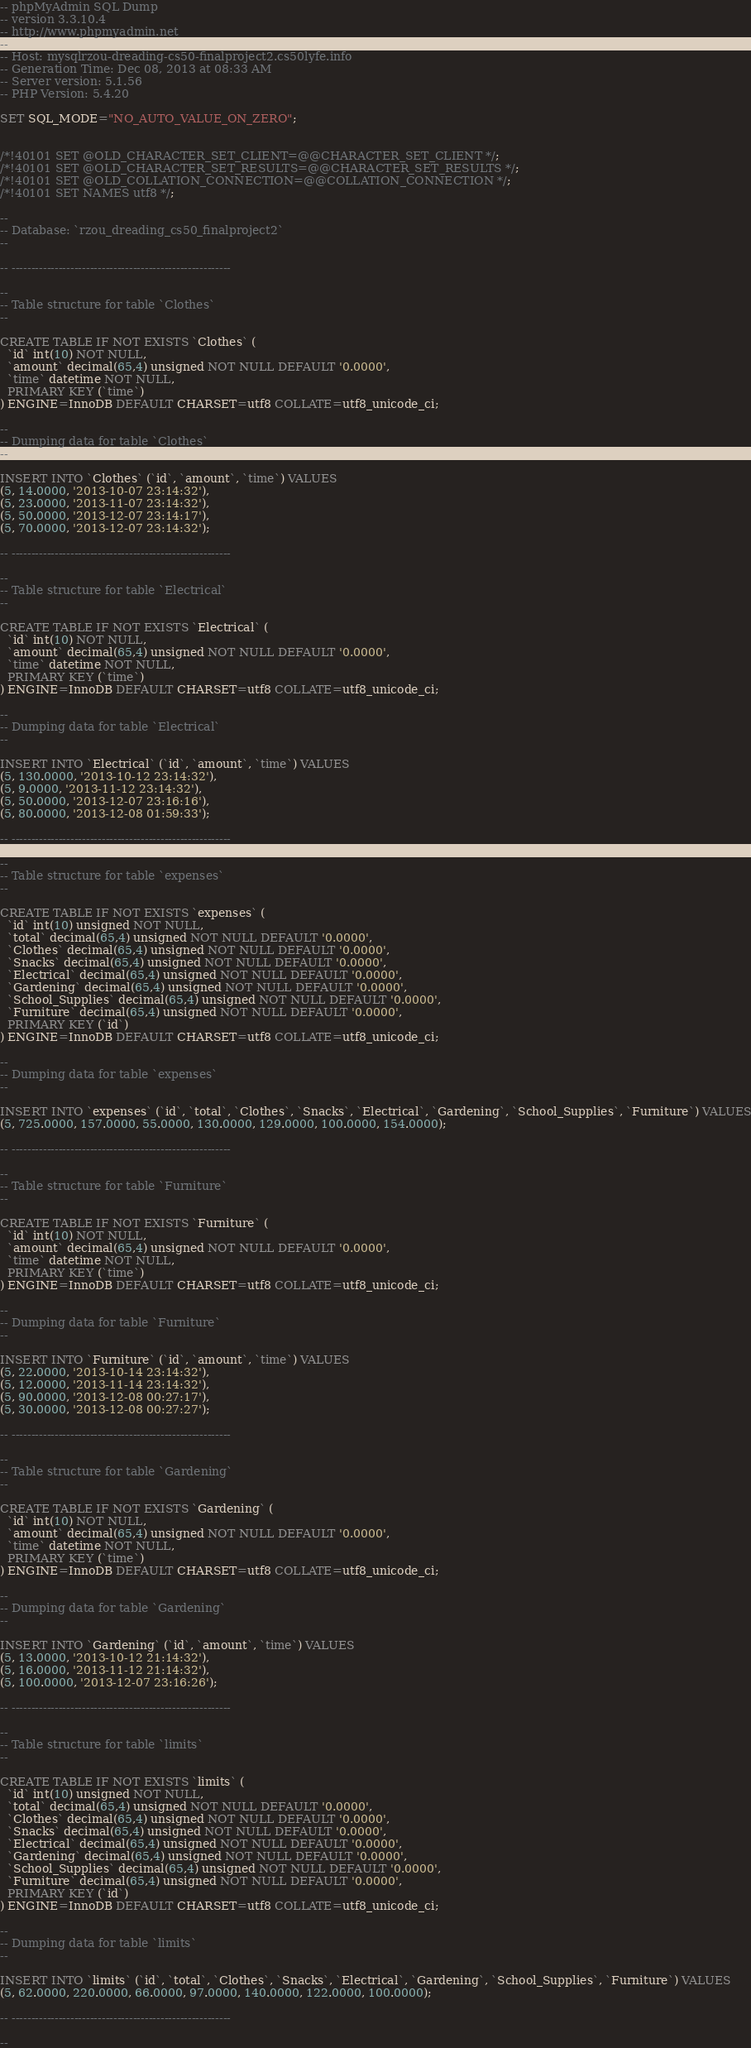<code> <loc_0><loc_0><loc_500><loc_500><_SQL_>-- phpMyAdmin SQL Dump
-- version 3.3.10.4
-- http://www.phpmyadmin.net
--
-- Host: mysqlrzou-dreading-cs50-finalproject2.cs50lyfe.info
-- Generation Time: Dec 08, 2013 at 08:33 AM
-- Server version: 5.1.56
-- PHP Version: 5.4.20

SET SQL_MODE="NO_AUTO_VALUE_ON_ZERO";


/*!40101 SET @OLD_CHARACTER_SET_CLIENT=@@CHARACTER_SET_CLIENT */;
/*!40101 SET @OLD_CHARACTER_SET_RESULTS=@@CHARACTER_SET_RESULTS */;
/*!40101 SET @OLD_COLLATION_CONNECTION=@@COLLATION_CONNECTION */;
/*!40101 SET NAMES utf8 */;

--
-- Database: `rzou_dreading_cs50_finalproject2`
--

-- --------------------------------------------------------

--
-- Table structure for table `Clothes`
--

CREATE TABLE IF NOT EXISTS `Clothes` (
  `id` int(10) NOT NULL,
  `amount` decimal(65,4) unsigned NOT NULL DEFAULT '0.0000',
  `time` datetime NOT NULL,
  PRIMARY KEY (`time`)
) ENGINE=InnoDB DEFAULT CHARSET=utf8 COLLATE=utf8_unicode_ci;

--
-- Dumping data for table `Clothes`
--

INSERT INTO `Clothes` (`id`, `amount`, `time`) VALUES
(5, 14.0000, '2013-10-07 23:14:32'),
(5, 23.0000, '2013-11-07 23:14:32'),
(5, 50.0000, '2013-12-07 23:14:17'),
(5, 70.0000, '2013-12-07 23:14:32');

-- --------------------------------------------------------

--
-- Table structure for table `Electrical`
--

CREATE TABLE IF NOT EXISTS `Electrical` (
  `id` int(10) NOT NULL,
  `amount` decimal(65,4) unsigned NOT NULL DEFAULT '0.0000',
  `time` datetime NOT NULL,
  PRIMARY KEY (`time`)
) ENGINE=InnoDB DEFAULT CHARSET=utf8 COLLATE=utf8_unicode_ci;

--
-- Dumping data for table `Electrical`
--

INSERT INTO `Electrical` (`id`, `amount`, `time`) VALUES
(5, 130.0000, '2013-10-12 23:14:32'),
(5, 9.0000, '2013-11-12 23:14:32'),
(5, 50.0000, '2013-12-07 23:16:16'),
(5, 80.0000, '2013-12-08 01:59:33');

-- --------------------------------------------------------

--
-- Table structure for table `expenses`
--

CREATE TABLE IF NOT EXISTS `expenses` (
  `id` int(10) unsigned NOT NULL,
  `total` decimal(65,4) unsigned NOT NULL DEFAULT '0.0000',
  `Clothes` decimal(65,4) unsigned NOT NULL DEFAULT '0.0000',
  `Snacks` decimal(65,4) unsigned NOT NULL DEFAULT '0.0000',
  `Electrical` decimal(65,4) unsigned NOT NULL DEFAULT '0.0000',
  `Gardening` decimal(65,4) unsigned NOT NULL DEFAULT '0.0000',
  `School_Supplies` decimal(65,4) unsigned NOT NULL DEFAULT '0.0000',
  `Furniture` decimal(65,4) unsigned NOT NULL DEFAULT '0.0000',
  PRIMARY KEY (`id`)
) ENGINE=InnoDB DEFAULT CHARSET=utf8 COLLATE=utf8_unicode_ci;

--
-- Dumping data for table `expenses`
--

INSERT INTO `expenses` (`id`, `total`, `Clothes`, `Snacks`, `Electrical`, `Gardening`, `School_Supplies`, `Furniture`) VALUES
(5, 725.0000, 157.0000, 55.0000, 130.0000, 129.0000, 100.0000, 154.0000);

-- --------------------------------------------------------

--
-- Table structure for table `Furniture`
--

CREATE TABLE IF NOT EXISTS `Furniture` (
  `id` int(10) NOT NULL,
  `amount` decimal(65,4) unsigned NOT NULL DEFAULT '0.0000',
  `time` datetime NOT NULL,
  PRIMARY KEY (`time`)
) ENGINE=InnoDB DEFAULT CHARSET=utf8 COLLATE=utf8_unicode_ci;

--
-- Dumping data for table `Furniture`
--

INSERT INTO `Furniture` (`id`, `amount`, `time`) VALUES
(5, 22.0000, '2013-10-14 23:14:32'),
(5, 12.0000, '2013-11-14 23:14:32'),
(5, 90.0000, '2013-12-08 00:27:17'),
(5, 30.0000, '2013-12-08 00:27:27');

-- --------------------------------------------------------

--
-- Table structure for table `Gardening`
--

CREATE TABLE IF NOT EXISTS `Gardening` (
  `id` int(10) NOT NULL,
  `amount` decimal(65,4) unsigned NOT NULL DEFAULT '0.0000',
  `time` datetime NOT NULL,
  PRIMARY KEY (`time`)
) ENGINE=InnoDB DEFAULT CHARSET=utf8 COLLATE=utf8_unicode_ci;

--
-- Dumping data for table `Gardening`
--

INSERT INTO `Gardening` (`id`, `amount`, `time`) VALUES
(5, 13.0000, '2013-10-12 21:14:32'),
(5, 16.0000, '2013-11-12 21:14:32'),
(5, 100.0000, '2013-12-07 23:16:26');

-- --------------------------------------------------------

--
-- Table structure for table `limits`
--

CREATE TABLE IF NOT EXISTS `limits` (
  `id` int(10) unsigned NOT NULL,
  `total` decimal(65,4) unsigned NOT NULL DEFAULT '0.0000',
  `Clothes` decimal(65,4) unsigned NOT NULL DEFAULT '0.0000',
  `Snacks` decimal(65,4) unsigned NOT NULL DEFAULT '0.0000',
  `Electrical` decimal(65,4) unsigned NOT NULL DEFAULT '0.0000',
  `Gardening` decimal(65,4) unsigned NOT NULL DEFAULT '0.0000',
  `School_Supplies` decimal(65,4) unsigned NOT NULL DEFAULT '0.0000',
  `Furniture` decimal(65,4) unsigned NOT NULL DEFAULT '0.0000',
  PRIMARY KEY (`id`)
) ENGINE=InnoDB DEFAULT CHARSET=utf8 COLLATE=utf8_unicode_ci;

--
-- Dumping data for table `limits`
--

INSERT INTO `limits` (`id`, `total`, `Clothes`, `Snacks`, `Electrical`, `Gardening`, `School_Supplies`, `Furniture`) VALUES
(5, 62.0000, 220.0000, 66.0000, 97.0000, 140.0000, 122.0000, 100.0000);

-- --------------------------------------------------------

--</code> 